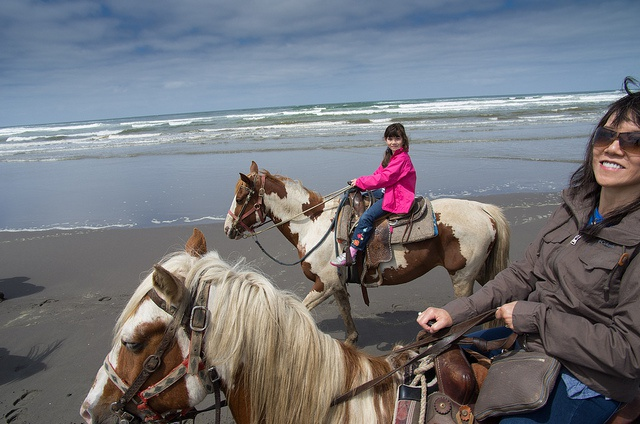Describe the objects in this image and their specific colors. I can see horse in gray, black, darkgray, and maroon tones, people in gray and black tones, horse in gray, black, darkgray, and maroon tones, handbag in gray, black, and maroon tones, and people in gray, black, magenta, purple, and violet tones in this image. 